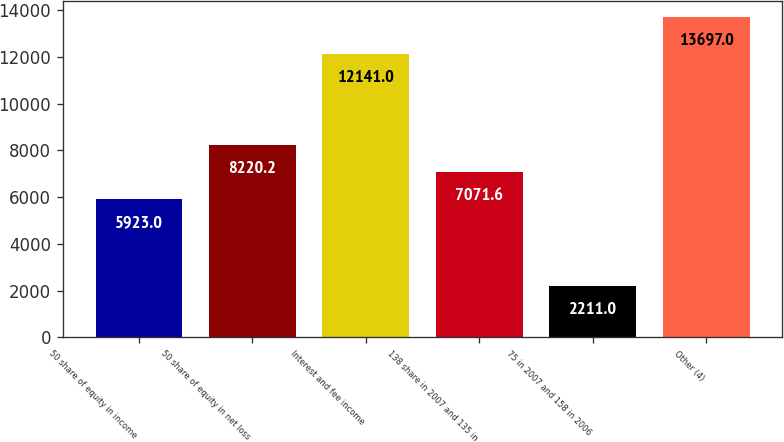Convert chart. <chart><loc_0><loc_0><loc_500><loc_500><bar_chart><fcel>50 share of equity in income<fcel>50 share of equity in net loss<fcel>Interest and fee income<fcel>138 share in 2007 and 135 in<fcel>75 in 2007 and 158 in 2006<fcel>Other (4)<nl><fcel>5923<fcel>8220.2<fcel>12141<fcel>7071.6<fcel>2211<fcel>13697<nl></chart> 